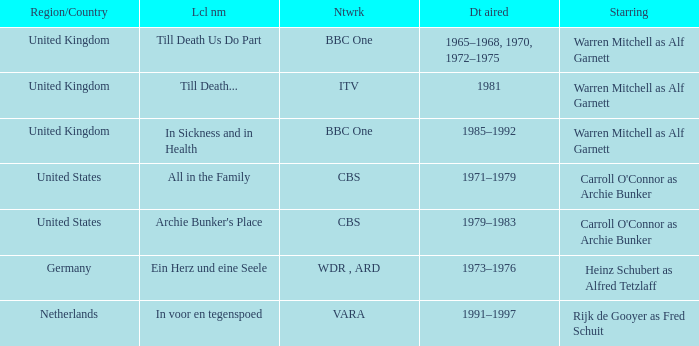What is the local name for the episodes that aired in 1981? Till Death... I'm looking to parse the entire table for insights. Could you assist me with that? {'header': ['Region/Country', 'Lcl nm', 'Ntwrk', 'Dt aired', 'Starring'], 'rows': [['United Kingdom', 'Till Death Us Do Part', 'BBC One', '1965–1968, 1970, 1972–1975', 'Warren Mitchell as Alf Garnett'], ['United Kingdom', 'Till Death...', 'ITV', '1981', 'Warren Mitchell as Alf Garnett'], ['United Kingdom', 'In Sickness and in Health', 'BBC One', '1985–1992', 'Warren Mitchell as Alf Garnett'], ['United States', 'All in the Family', 'CBS', '1971–1979', "Carroll O'Connor as Archie Bunker"], ['United States', "Archie Bunker's Place", 'CBS', '1979–1983', "Carroll O'Connor as Archie Bunker"], ['Germany', 'Ein Herz und eine Seele', 'WDR , ARD', '1973–1976', 'Heinz Schubert as Alfred Tetzlaff'], ['Netherlands', 'In voor en tegenspoed', 'VARA', '1991–1997', 'Rijk de Gooyer as Fred Schuit']]} 